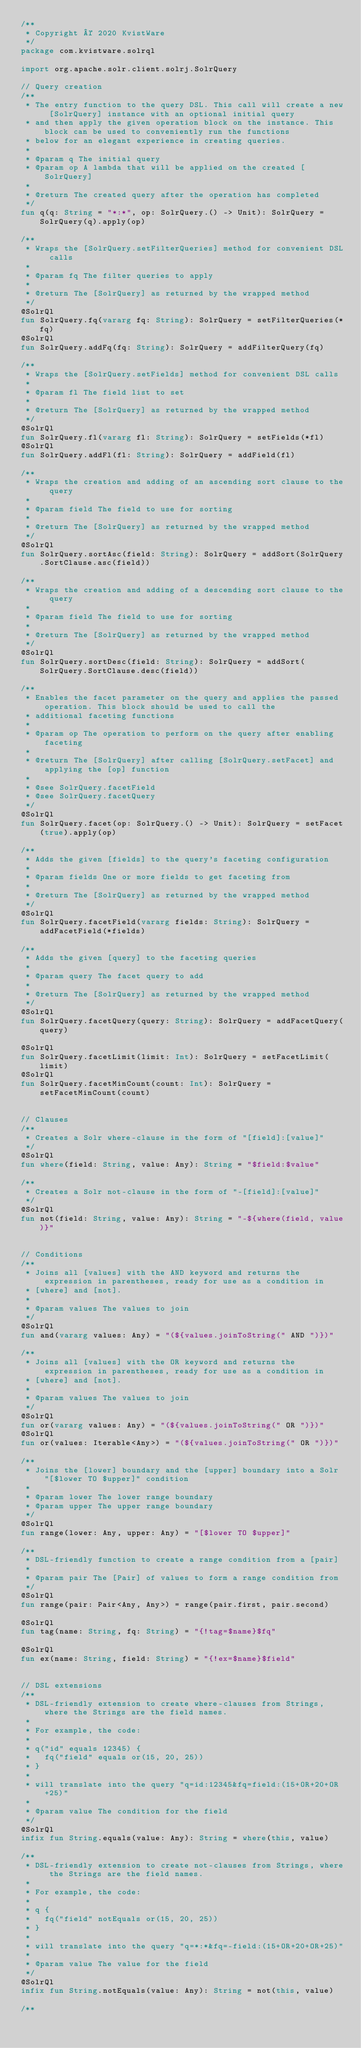<code> <loc_0><loc_0><loc_500><loc_500><_Kotlin_>/**
 * Copyright © 2020 KvistWare
 */
package com.kvistware.solrql

import org.apache.solr.client.solrj.SolrQuery

// Query creation
/**
 * The entry function to the query DSL. This call will create a new [SolrQuery] instance with an optional initial query
 * and then apply the given operation block on the instance. This block can be used to conveniently run the functions
 * below for an elegant experience in creating queries.
 *
 * @param q The initial query
 * @param op A lambda that will be applied on the created [SolrQuery]
 *
 * @return The created query after the operation has completed
 */
fun q(q: String = "*:*", op: SolrQuery.() -> Unit): SolrQuery = SolrQuery(q).apply(op)

/**
 * Wraps the [SolrQuery.setFilterQueries] method for convenient DSL calls
 *
 * @param fq The filter queries to apply
 *
 * @return The [SolrQuery] as returned by the wrapped method
 */
@SolrQl
fun SolrQuery.fq(vararg fq: String): SolrQuery = setFilterQueries(*fq)
@SolrQl
fun SolrQuery.addFq(fq: String): SolrQuery = addFilterQuery(fq)

/**
 * Wraps the [SolrQuery.setFields] method for convenient DSL calls
 *
 * @param fl The field list to set
 *
 * @return The [SolrQuery] as returned by the wrapped method
 */
@SolrQl
fun SolrQuery.fl(vararg fl: String): SolrQuery = setFields(*fl)
@SolrQl
fun SolrQuery.addFl(fl: String): SolrQuery = addField(fl)

/**
 * Wraps the creation and adding of an ascending sort clause to the query
 *
 * @param field The field to use for sorting
 *
 * @return The [SolrQuery] as returned by the wrapped method
 */
@SolrQl
fun SolrQuery.sortAsc(field: String): SolrQuery = addSort(SolrQuery.SortClause.asc(field))

/**
 * Wraps the creation and adding of a descending sort clause to the query
 *
 * @param field The field to use for sorting
 *
 * @return The [SolrQuery] as returned by the wrapped method
 */
@SolrQl
fun SolrQuery.sortDesc(field: String): SolrQuery = addSort(SolrQuery.SortClause.desc(field))

/**
 * Enables the facet parameter on the query and applies the passed operation. This block should be used to call the
 * additional faceting functions
 *
 * @param op The operation to perform on the query after enabling faceting
 *
 * @return The [SolrQuery] after calling [SolrQuery.setFacet] and applying the [op] function
 *
 * @see SolrQuery.facetField
 * @see SolrQuery.facetQuery
 */
@SolrQl
fun SolrQuery.facet(op: SolrQuery.() -> Unit): SolrQuery = setFacet(true).apply(op)

/**
 * Adds the given [fields] to the query's faceting configuration
 *
 * @param fields One or more fields to get faceting from
 *
 * @return The [SolrQuery] as returned by the wrapped method
 */
@SolrQl
fun SolrQuery.facetField(vararg fields: String): SolrQuery = addFacetField(*fields)

/**
 * Adds the given [query] to the faceting queries
 *
 * @param query The facet query to add
 *
 * @return The [SolrQuery] as returned by the wrapped method
 */
@SolrQl
fun SolrQuery.facetQuery(query: String): SolrQuery = addFacetQuery(query)

@SolrQl
fun SolrQuery.facetLimit(limit: Int): SolrQuery = setFacetLimit(limit)
@SolrQl
fun SolrQuery.facetMinCount(count: Int): SolrQuery = setFacetMinCount(count)


// Clauses
/**
 * Creates a Solr where-clause in the form of "[field]:[value]"
 */
@SolrQl
fun where(field: String, value: Any): String = "$field:$value"

/**
 * Creates a Solr not-clause in the form of "-[field]:[value]"
 */
@SolrQl
fun not(field: String, value: Any): String = "-${where(field, value)}"


// Conditions
/**
 * Joins all [values] with the AND keyword and returns the expression in parentheses, ready for use as a condition in
 * [where] and [not].
 *
 * @param values The values to join
 */
@SolrQl
fun and(vararg values: Any) = "(${values.joinToString(" AND ")})"

/**
 * Joins all [values] with the OR keyword and returns the expression in parentheses, ready for use as a condition in
 * [where] and [not].
 *
 * @param values The values to join
 */
@SolrQl
fun or(vararg values: Any) = "(${values.joinToString(" OR ")})"
@SolrQl
fun or(values: Iterable<Any>) = "(${values.joinToString(" OR ")})"

/**
 * Joins the [lower] boundary and the [upper] boundary into a Solr "[$lower TO $upper]" condition
 *
 * @param lower The lower range boundary
 * @param upper The upper range boundary
 */
@SolrQl
fun range(lower: Any, upper: Any) = "[$lower TO $upper]"

/**
 * DSL-friendly function to create a range condition from a [pair]
 *
 * @param pair The [Pair] of values to form a range condition from
 */
@SolrQl
fun range(pair: Pair<Any, Any>) = range(pair.first, pair.second)

@SolrQl
fun tag(name: String, fq: String) = "{!tag=$name}$fq"

@SolrQl
fun ex(name: String, field: String) = "{!ex=$name}$field"


// DSL extensions
/**
 * DSL-friendly extension to create where-clauses from Strings, where the Strings are the field names.
 *
 * For example, the code:
 *
 * q("id" equals 12345) {
 *   fq("field" equals or(15, 20, 25))
 * }
 *
 * will translate into the query "q=id:12345&fq=field:(15+OR+20+OR+25)"
 *
 * @param value The condition for the field
 */
@SolrQl
infix fun String.equals(value: Any): String = where(this, value)

/**
 * DSL-friendly extension to create not-clauses from Strings, where the Strings are the field names.
 *
 * For example, the code:
 *
 * q {
 *   fq("field" notEquals or(15, 20, 25))
 * }
 *
 * will translate into the query "q=*:*&fq=-field:(15+OR+20+OR+25)"
 *
 * @param value The value for the field
 */
@SolrQl
infix fun String.notEquals(value: Any): String = not(this, value)

/**</code> 